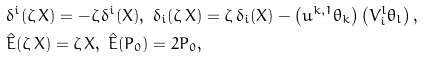Convert formula to latex. <formula><loc_0><loc_0><loc_500><loc_500>& \delta ^ { i } ( \zeta \, X ) = - \zeta \, \delta ^ { i } ( X ) , \ \delta _ { i } ( \zeta \, X ) = \zeta \, \delta _ { i } ( X ) - \left ( u ^ { k , 1 } \theta _ { k } \right ) \left ( V ^ { l } _ { i } \theta _ { l } \right ) , \\ & \hat { E } ( \zeta \, X ) = \zeta \, X , \ \hat { E } ( P _ { 0 } ) = 2 P _ { 0 } ,</formula> 